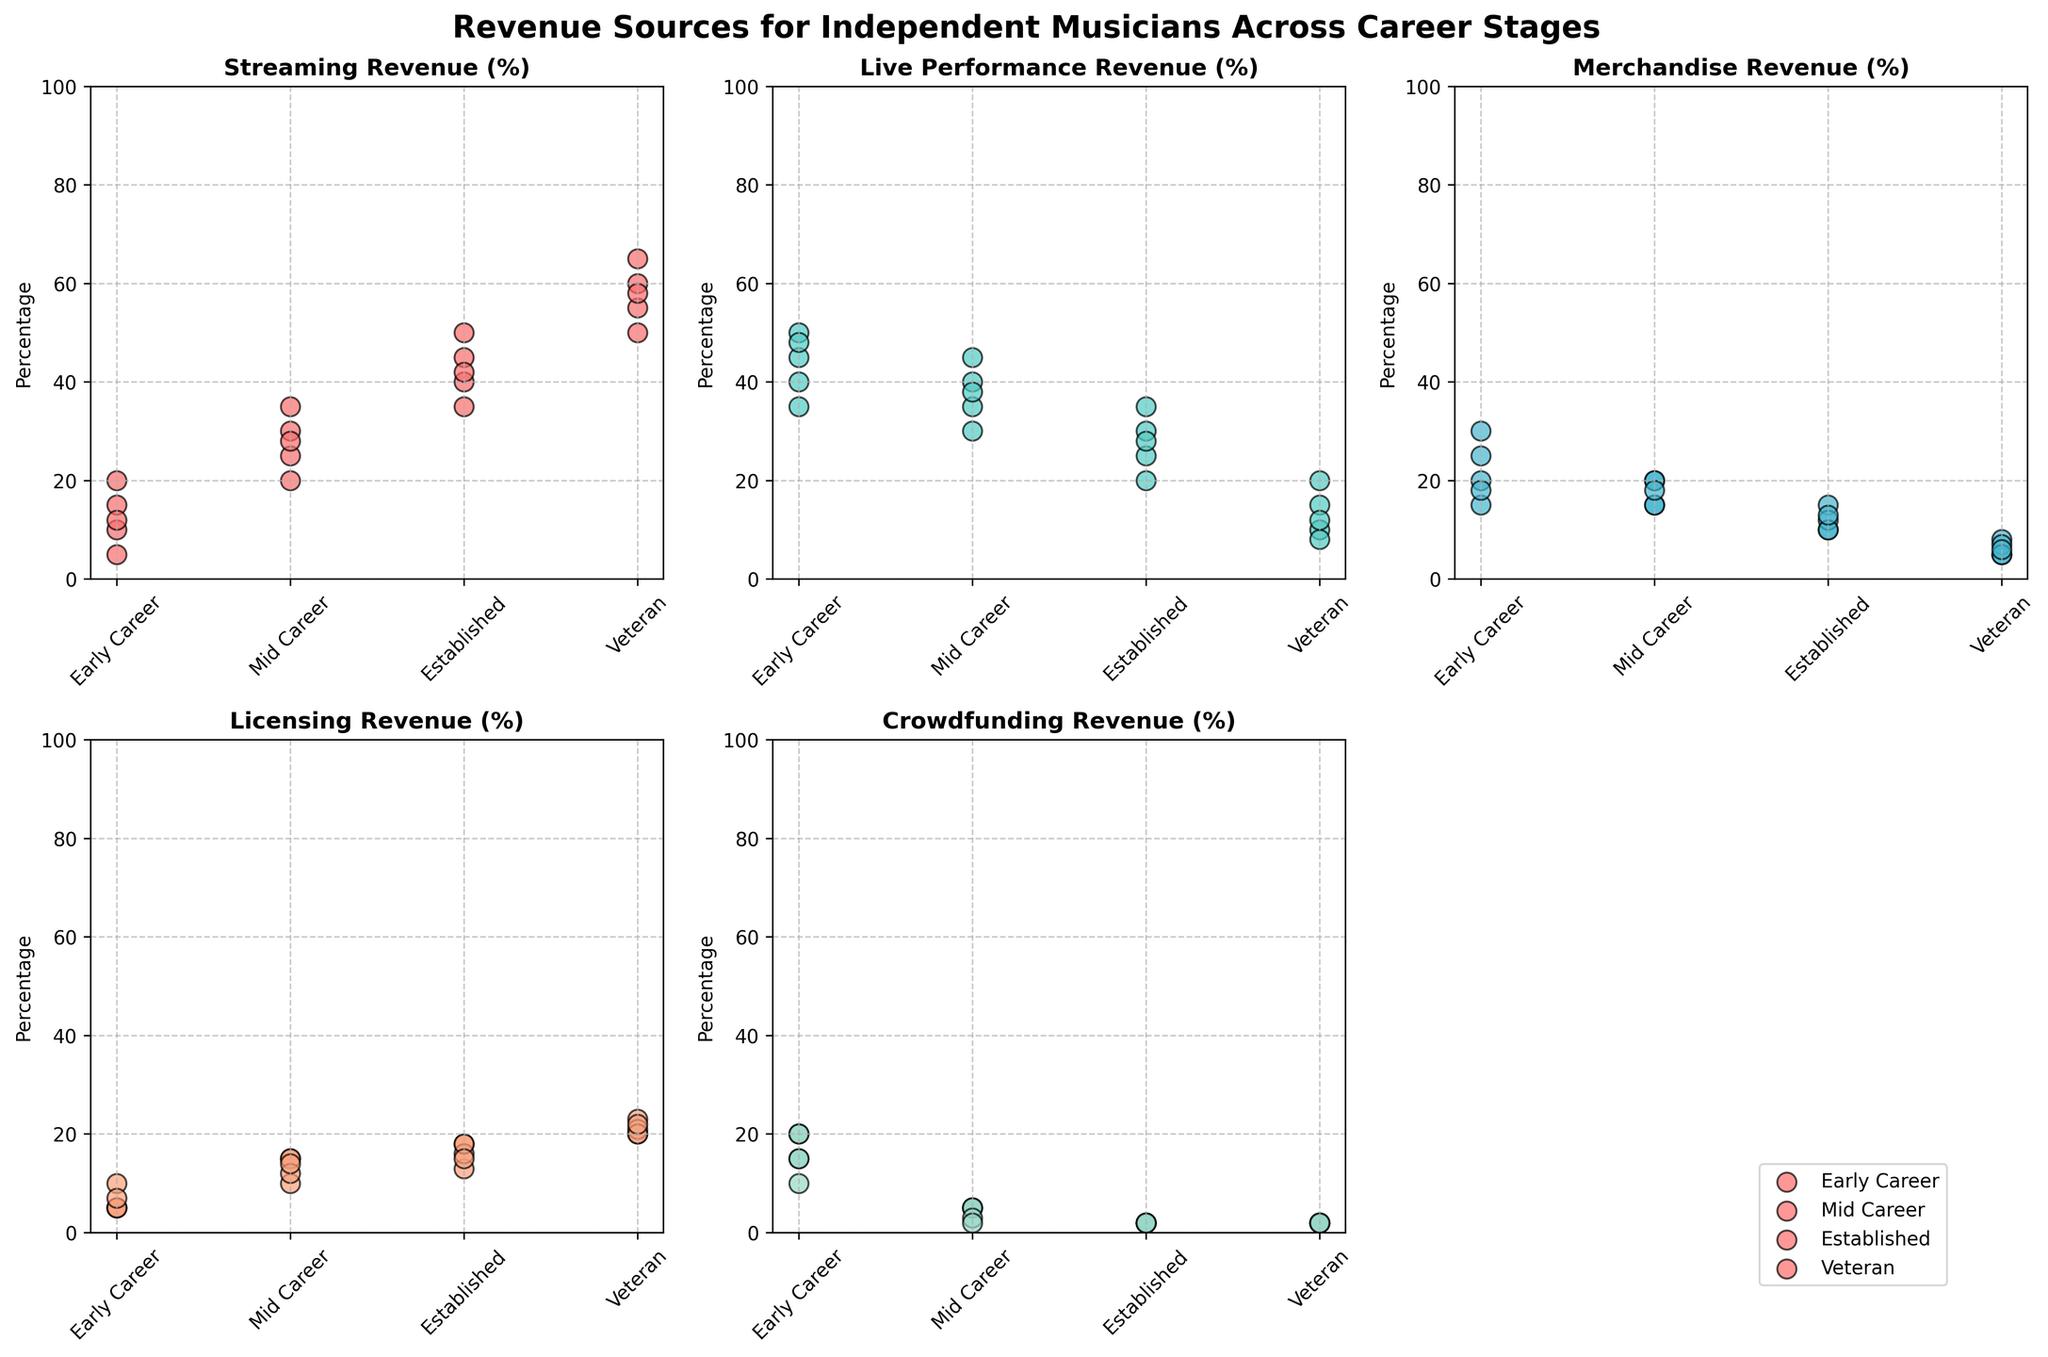What are the average streaming revenue percentages for early career and veteran musicians? To find the average streaming revenue percentage for early career musicians, sum the percentages (10, 15, 20, 5, 12) and divide by 5. For veteran musicians, sum the percentages (55, 60, 50, 65, 58) and divide by 5. Average for early career = (10+15+20+5+12)/5 = 12.4%. Average for veteran = (55+60+50+65+58)/5 = 57.6%.
Answer: 12.4% (early career), 57.6% (veteran) Which revenue source has the highest variation for established musicians? Look at the scatter plots for established musicians and observe the range of the revenue percentages. Streaming revenue varies from 35% to 50%. Live performance revenue varies from 20% to 35%. Merchandise revenue varies from 10% to 15%. Licensing revenue varies from 13% to 18%. Crowdfunding revenue is constant at 2%. Streaming revenue shows the highest variation.
Answer: Streaming revenue How do the live performance revenues compare between early career and mid-career musicians? Review the scatter plots for live performance revenue. Early career musicians range from 35% to 50%, whereas mid-career musicians range from 30% to 45%. Both career stages overlap but early career musicians can have slightly higher percentages.
Answer: Early career ranges 35%-50%, Mid career ranges 30%-45% Which career stage has the least variability in crowdfunding revenue? Observe the scatter plots for crowdfunding revenue across career stages. Established musicians and veteran musicians both have crowdfunding revenue consistently at 2%, showing the least variability.
Answer: Established and veteran What is the difference in average licensing revenue between early career and established musicians? Find the average licensing revenue for early career (5% each, check all instances to ensure consistency) and for established musicians (18, 13, 16, 18, 15). Calculate the average for established: (18+13+16+18+15)/5 = 16%. Difference = 16% - 5% = 11%.
Answer: 11% Between which career stages is the disparity in streaming revenue the greatest? Compare the maximum and minimum streaming revenue percentages across all career stages. The greatest disparity is between early career (5% to 20%) and veteran (55% to 65%). The largest gap occurs between the highest percentage for veterans and the lowest for early career (65% - 5% = 60%).
Answer: Early career and veteran Which revenue source for mid-career musicians shows the least scatter in its distribution? Review the scatter plots for mid-career musicians. Crowdfunding revenue for mid-career musicians ranges between 2% and 5%, showing the least scatter compared to other sources.
Answer: Crowdfunding revenue Do early career musicians or established musicians show more variability in merchandise revenue? Observe the scatter plots for merchandise revenue for both stages. Early career ranges from 15% to 30% whereas established ranges from 10% to 15%. Early career musicians show more variability.
Answer: Early career What percentage range does veteran musicians' licensing revenue fall into? Look at the scatter plot for veteran musicians. Licensing revenue for veteran musicians varies from 20% to 23%.
Answer: 20% to 23% 